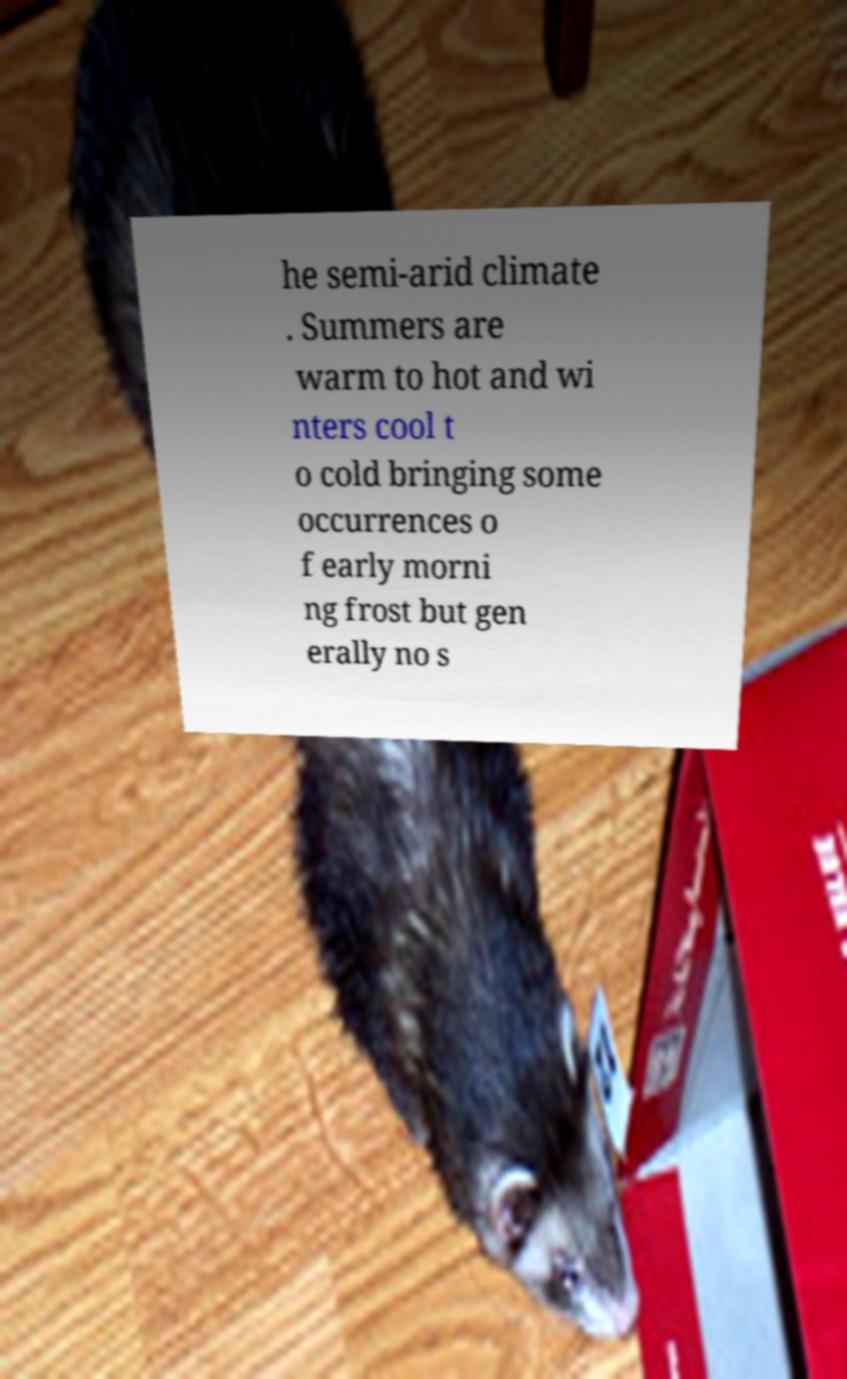I need the written content from this picture converted into text. Can you do that? he semi-arid climate . Summers are warm to hot and wi nters cool t o cold bringing some occurrences o f early morni ng frost but gen erally no s 